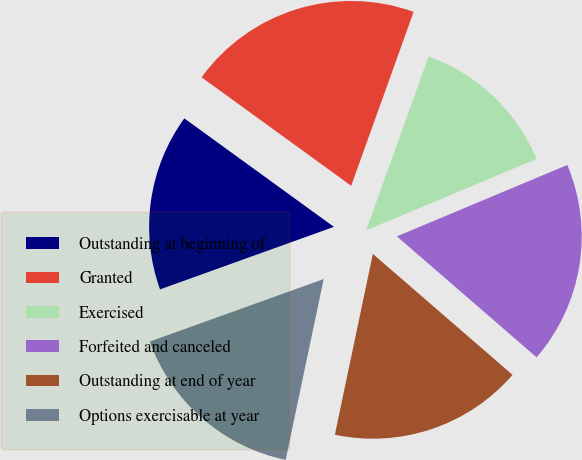Convert chart to OTSL. <chart><loc_0><loc_0><loc_500><loc_500><pie_chart><fcel>Outstanding at beginning of<fcel>Granted<fcel>Exercised<fcel>Forfeited and canceled<fcel>Outstanding at end of year<fcel>Options exercisable at year<nl><fcel>15.48%<fcel>20.5%<fcel>13.2%<fcel>17.67%<fcel>16.94%<fcel>16.21%<nl></chart> 